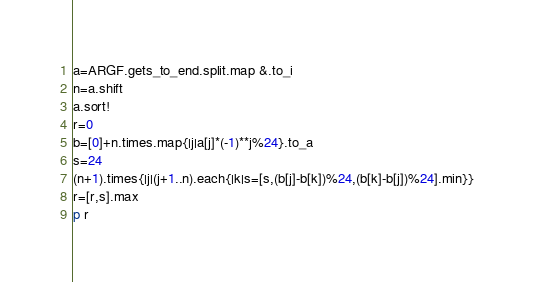<code> <loc_0><loc_0><loc_500><loc_500><_Crystal_>a=ARGF.gets_to_end.split.map &.to_i
n=a.shift
a.sort!
r=0
b=[0]+n.times.map{|j|a[j]*(-1)**j%24}.to_a
s=24
(n+1).times{|j|(j+1..n).each{|k|s=[s,(b[j]-b[k])%24,(b[k]-b[j])%24].min}}
r=[r,s].max
p r</code> 